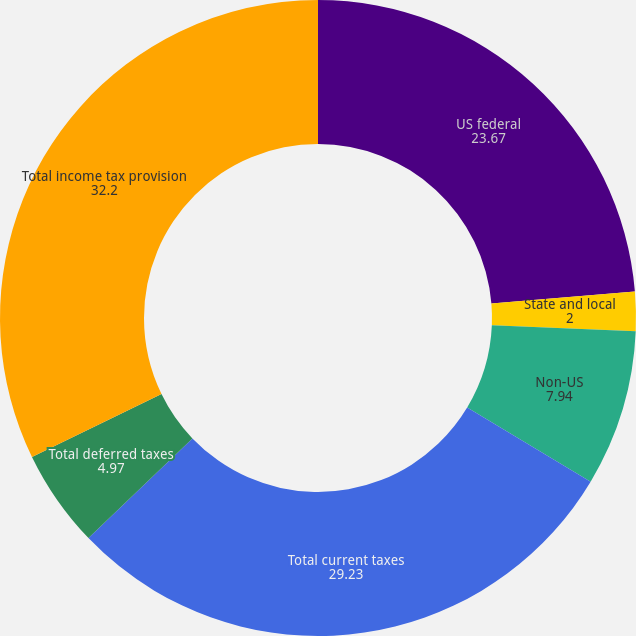Convert chart to OTSL. <chart><loc_0><loc_0><loc_500><loc_500><pie_chart><fcel>US federal<fcel>State and local<fcel>Non-US<fcel>Total current taxes<fcel>Total deferred taxes<fcel>Total income tax provision<nl><fcel>23.67%<fcel>2.0%<fcel>7.94%<fcel>29.23%<fcel>4.97%<fcel>32.2%<nl></chart> 